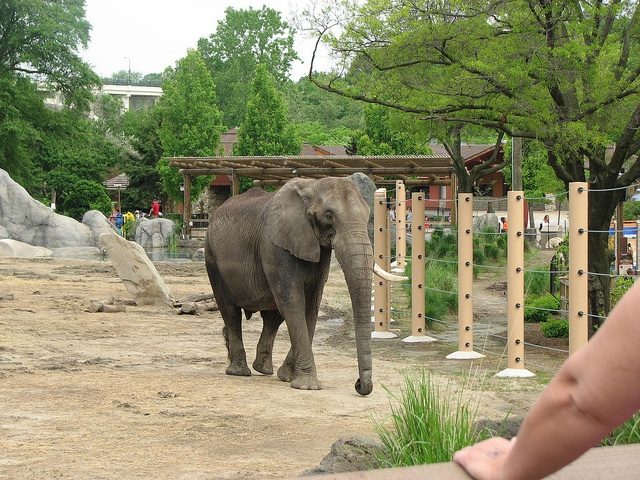Describe the objects in this image and their specific colors. I can see elephant in darkgreen, gray, and black tones, people in darkgreen, brown, tan, and salmon tones, people in darkgreen, gray, and olive tones, people in darkgreen, brown, gray, and maroon tones, and people in darkgreen, darkgray, gray, black, and brown tones in this image. 